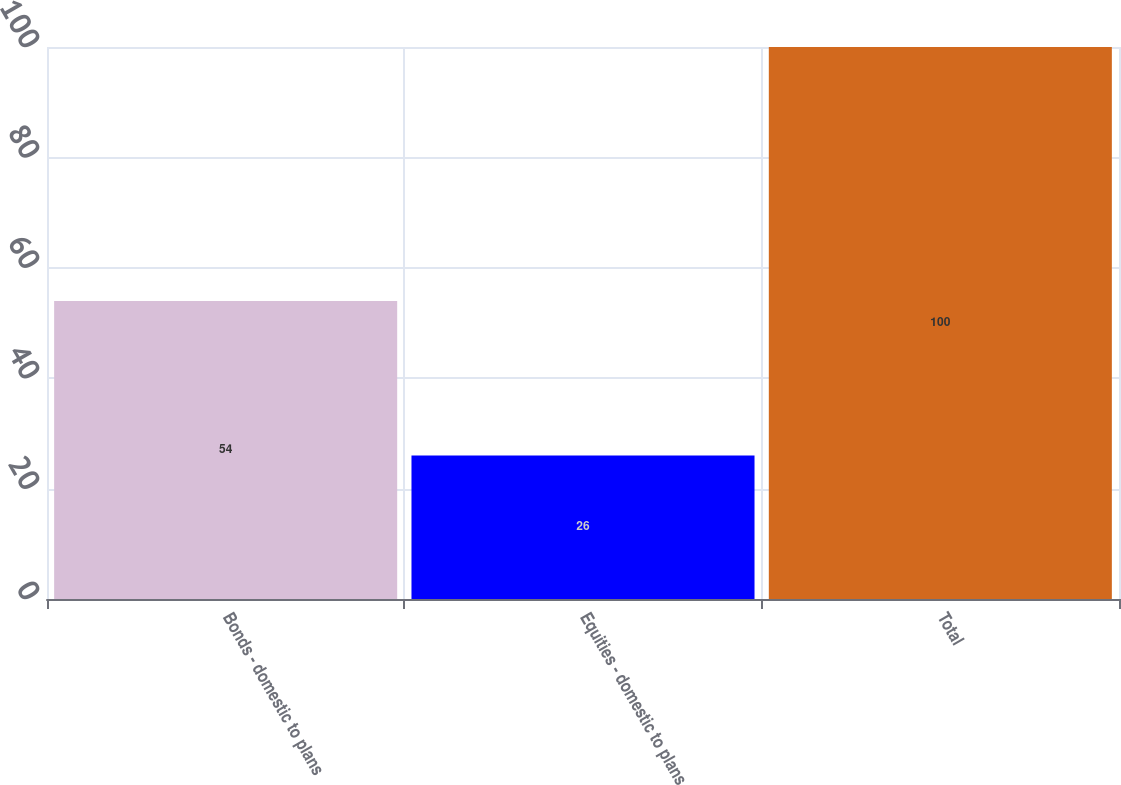Convert chart to OTSL. <chart><loc_0><loc_0><loc_500><loc_500><bar_chart><fcel>Bonds - domestic to plans<fcel>Equities - domestic to plans<fcel>Total<nl><fcel>54<fcel>26<fcel>100<nl></chart> 